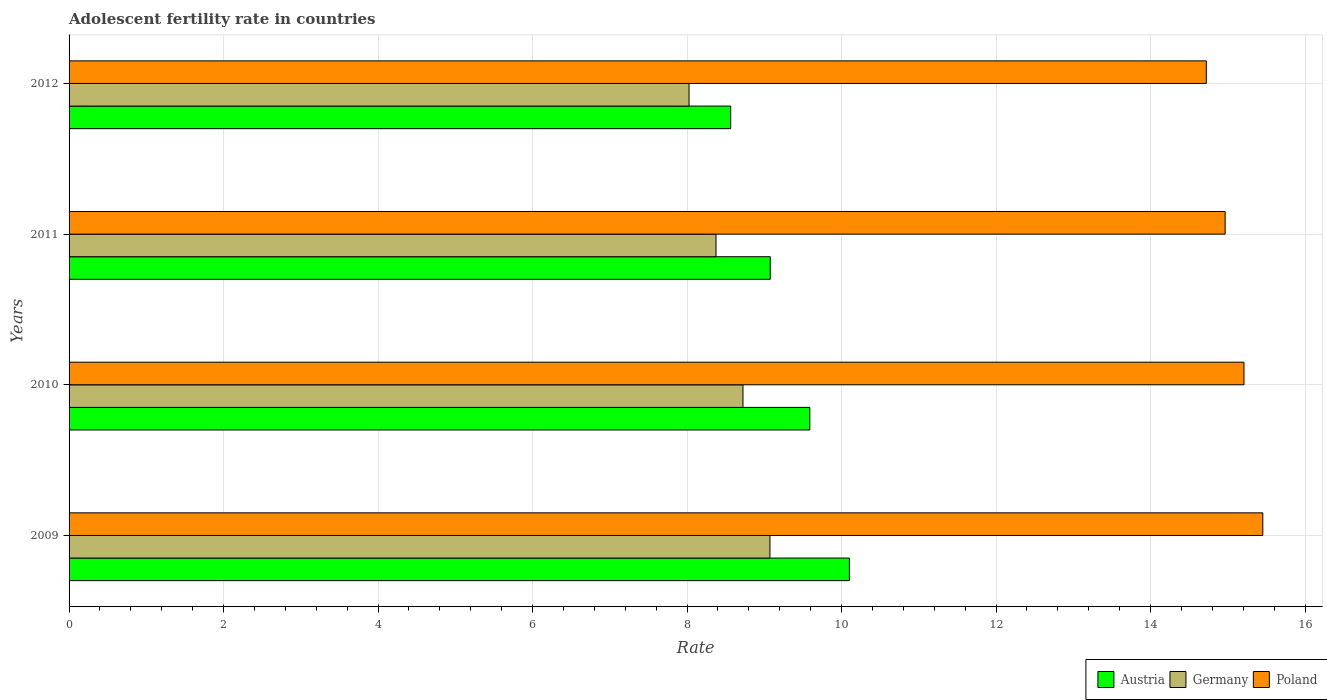How many different coloured bars are there?
Make the answer very short. 3. How many groups of bars are there?
Ensure brevity in your answer.  4. How many bars are there on the 3rd tick from the top?
Give a very brief answer. 3. What is the label of the 4th group of bars from the top?
Give a very brief answer. 2009. In how many cases, is the number of bars for a given year not equal to the number of legend labels?
Make the answer very short. 0. What is the adolescent fertility rate in Poland in 2012?
Your answer should be very brief. 14.72. Across all years, what is the maximum adolescent fertility rate in Austria?
Offer a terse response. 10.1. Across all years, what is the minimum adolescent fertility rate in Poland?
Offer a very short reply. 14.72. In which year was the adolescent fertility rate in Austria minimum?
Ensure brevity in your answer.  2012. What is the total adolescent fertility rate in Poland in the graph?
Provide a short and direct response. 60.35. What is the difference between the adolescent fertility rate in Austria in 2009 and that in 2010?
Give a very brief answer. 0.51. What is the difference between the adolescent fertility rate in Poland in 2011 and the adolescent fertility rate in Austria in 2012?
Your answer should be very brief. 6.4. What is the average adolescent fertility rate in Germany per year?
Your answer should be very brief. 8.55. In the year 2011, what is the difference between the adolescent fertility rate in Germany and adolescent fertility rate in Austria?
Offer a terse response. -0.7. In how many years, is the adolescent fertility rate in Austria greater than 15.6 ?
Your answer should be compact. 0. What is the ratio of the adolescent fertility rate in Poland in 2009 to that in 2010?
Offer a terse response. 1.02. Is the adolescent fertility rate in Poland in 2011 less than that in 2012?
Your response must be concise. No. Is the difference between the adolescent fertility rate in Germany in 2011 and 2012 greater than the difference between the adolescent fertility rate in Austria in 2011 and 2012?
Your answer should be compact. No. What is the difference between the highest and the second highest adolescent fertility rate in Germany?
Provide a short and direct response. 0.35. What is the difference between the highest and the lowest adolescent fertility rate in Germany?
Offer a very short reply. 1.05. In how many years, is the adolescent fertility rate in Poland greater than the average adolescent fertility rate in Poland taken over all years?
Your answer should be compact. 2. What does the 2nd bar from the top in 2009 represents?
Your answer should be compact. Germany. What does the 3rd bar from the bottom in 2009 represents?
Keep it short and to the point. Poland. How many bars are there?
Offer a very short reply. 12. How many years are there in the graph?
Keep it short and to the point. 4. What is the difference between two consecutive major ticks on the X-axis?
Your answer should be very brief. 2. Where does the legend appear in the graph?
Offer a very short reply. Bottom right. How many legend labels are there?
Your answer should be compact. 3. How are the legend labels stacked?
Make the answer very short. Horizontal. What is the title of the graph?
Provide a succinct answer. Adolescent fertility rate in countries. Does "Ecuador" appear as one of the legend labels in the graph?
Offer a terse response. No. What is the label or title of the X-axis?
Ensure brevity in your answer.  Rate. What is the Rate of Austria in 2009?
Ensure brevity in your answer.  10.1. What is the Rate in Germany in 2009?
Make the answer very short. 9.07. What is the Rate of Poland in 2009?
Give a very brief answer. 15.45. What is the Rate of Austria in 2010?
Give a very brief answer. 9.59. What is the Rate in Germany in 2010?
Offer a terse response. 8.72. What is the Rate of Poland in 2010?
Provide a succinct answer. 15.21. What is the Rate in Austria in 2011?
Your answer should be very brief. 9.08. What is the Rate of Germany in 2011?
Give a very brief answer. 8.38. What is the Rate of Poland in 2011?
Your answer should be compact. 14.97. What is the Rate in Austria in 2012?
Make the answer very short. 8.56. What is the Rate in Germany in 2012?
Ensure brevity in your answer.  8.03. What is the Rate of Poland in 2012?
Ensure brevity in your answer.  14.72. Across all years, what is the maximum Rate in Austria?
Provide a short and direct response. 10.1. Across all years, what is the maximum Rate of Germany?
Make the answer very short. 9.07. Across all years, what is the maximum Rate of Poland?
Provide a short and direct response. 15.45. Across all years, what is the minimum Rate of Austria?
Provide a succinct answer. 8.56. Across all years, what is the minimum Rate of Germany?
Your answer should be compact. 8.03. Across all years, what is the minimum Rate of Poland?
Give a very brief answer. 14.72. What is the total Rate in Austria in the graph?
Offer a terse response. 37.33. What is the total Rate in Germany in the graph?
Make the answer very short. 34.2. What is the total Rate of Poland in the graph?
Make the answer very short. 60.35. What is the difference between the Rate of Austria in 2009 and that in 2010?
Provide a short and direct response. 0.51. What is the difference between the Rate of Germany in 2009 and that in 2010?
Your response must be concise. 0.35. What is the difference between the Rate of Poland in 2009 and that in 2010?
Your answer should be compact. 0.24. What is the difference between the Rate of Austria in 2009 and that in 2011?
Your response must be concise. 1.02. What is the difference between the Rate in Germany in 2009 and that in 2011?
Your answer should be compact. 0.7. What is the difference between the Rate in Poland in 2009 and that in 2011?
Keep it short and to the point. 0.49. What is the difference between the Rate in Austria in 2009 and that in 2012?
Provide a short and direct response. 1.54. What is the difference between the Rate in Germany in 2009 and that in 2012?
Offer a very short reply. 1.05. What is the difference between the Rate of Poland in 2009 and that in 2012?
Your answer should be compact. 0.73. What is the difference between the Rate in Austria in 2010 and that in 2011?
Your answer should be compact. 0.51. What is the difference between the Rate in Germany in 2010 and that in 2011?
Provide a short and direct response. 0.35. What is the difference between the Rate of Poland in 2010 and that in 2011?
Provide a succinct answer. 0.24. What is the difference between the Rate of Austria in 2010 and that in 2012?
Provide a short and direct response. 1.02. What is the difference between the Rate of Germany in 2010 and that in 2012?
Keep it short and to the point. 0.7. What is the difference between the Rate in Poland in 2010 and that in 2012?
Offer a very short reply. 0.49. What is the difference between the Rate in Austria in 2011 and that in 2012?
Offer a very short reply. 0.51. What is the difference between the Rate in Germany in 2011 and that in 2012?
Offer a terse response. 0.35. What is the difference between the Rate in Poland in 2011 and that in 2012?
Offer a terse response. 0.24. What is the difference between the Rate of Austria in 2009 and the Rate of Germany in 2010?
Your answer should be compact. 1.38. What is the difference between the Rate in Austria in 2009 and the Rate in Poland in 2010?
Make the answer very short. -5.11. What is the difference between the Rate of Germany in 2009 and the Rate of Poland in 2010?
Your response must be concise. -6.14. What is the difference between the Rate in Austria in 2009 and the Rate in Germany in 2011?
Keep it short and to the point. 1.73. What is the difference between the Rate in Austria in 2009 and the Rate in Poland in 2011?
Keep it short and to the point. -4.86. What is the difference between the Rate in Germany in 2009 and the Rate in Poland in 2011?
Keep it short and to the point. -5.89. What is the difference between the Rate of Austria in 2009 and the Rate of Germany in 2012?
Give a very brief answer. 2.08. What is the difference between the Rate in Austria in 2009 and the Rate in Poland in 2012?
Give a very brief answer. -4.62. What is the difference between the Rate in Germany in 2009 and the Rate in Poland in 2012?
Offer a very short reply. -5.65. What is the difference between the Rate in Austria in 2010 and the Rate in Germany in 2011?
Ensure brevity in your answer.  1.21. What is the difference between the Rate of Austria in 2010 and the Rate of Poland in 2011?
Keep it short and to the point. -5.38. What is the difference between the Rate in Germany in 2010 and the Rate in Poland in 2011?
Offer a very short reply. -6.24. What is the difference between the Rate of Austria in 2010 and the Rate of Germany in 2012?
Offer a terse response. 1.56. What is the difference between the Rate in Austria in 2010 and the Rate in Poland in 2012?
Your answer should be very brief. -5.13. What is the difference between the Rate of Germany in 2010 and the Rate of Poland in 2012?
Offer a terse response. -6. What is the difference between the Rate in Austria in 2011 and the Rate in Germany in 2012?
Your response must be concise. 1.05. What is the difference between the Rate of Austria in 2011 and the Rate of Poland in 2012?
Your answer should be compact. -5.64. What is the difference between the Rate of Germany in 2011 and the Rate of Poland in 2012?
Your answer should be compact. -6.35. What is the average Rate of Austria per year?
Offer a terse response. 9.33. What is the average Rate of Germany per year?
Your answer should be very brief. 8.55. What is the average Rate of Poland per year?
Your response must be concise. 15.09. In the year 2009, what is the difference between the Rate of Austria and Rate of Germany?
Keep it short and to the point. 1.03. In the year 2009, what is the difference between the Rate of Austria and Rate of Poland?
Make the answer very short. -5.35. In the year 2009, what is the difference between the Rate of Germany and Rate of Poland?
Make the answer very short. -6.38. In the year 2010, what is the difference between the Rate in Austria and Rate in Germany?
Your response must be concise. 0.87. In the year 2010, what is the difference between the Rate of Austria and Rate of Poland?
Provide a succinct answer. -5.62. In the year 2010, what is the difference between the Rate in Germany and Rate in Poland?
Your response must be concise. -6.49. In the year 2011, what is the difference between the Rate of Austria and Rate of Germany?
Give a very brief answer. 0.7. In the year 2011, what is the difference between the Rate in Austria and Rate in Poland?
Keep it short and to the point. -5.89. In the year 2011, what is the difference between the Rate of Germany and Rate of Poland?
Make the answer very short. -6.59. In the year 2012, what is the difference between the Rate in Austria and Rate in Germany?
Make the answer very short. 0.54. In the year 2012, what is the difference between the Rate of Austria and Rate of Poland?
Offer a very short reply. -6.16. In the year 2012, what is the difference between the Rate in Germany and Rate in Poland?
Your answer should be compact. -6.7. What is the ratio of the Rate of Austria in 2009 to that in 2010?
Your response must be concise. 1.05. What is the ratio of the Rate of Germany in 2009 to that in 2010?
Your response must be concise. 1.04. What is the ratio of the Rate in Austria in 2009 to that in 2011?
Your answer should be very brief. 1.11. What is the ratio of the Rate of Poland in 2009 to that in 2011?
Your answer should be compact. 1.03. What is the ratio of the Rate in Austria in 2009 to that in 2012?
Provide a succinct answer. 1.18. What is the ratio of the Rate of Germany in 2009 to that in 2012?
Your answer should be compact. 1.13. What is the ratio of the Rate in Poland in 2009 to that in 2012?
Keep it short and to the point. 1.05. What is the ratio of the Rate of Austria in 2010 to that in 2011?
Provide a short and direct response. 1.06. What is the ratio of the Rate of Germany in 2010 to that in 2011?
Ensure brevity in your answer.  1.04. What is the ratio of the Rate of Poland in 2010 to that in 2011?
Offer a very short reply. 1.02. What is the ratio of the Rate of Austria in 2010 to that in 2012?
Keep it short and to the point. 1.12. What is the ratio of the Rate of Germany in 2010 to that in 2012?
Make the answer very short. 1.09. What is the ratio of the Rate in Poland in 2010 to that in 2012?
Provide a short and direct response. 1.03. What is the ratio of the Rate in Austria in 2011 to that in 2012?
Your response must be concise. 1.06. What is the ratio of the Rate of Germany in 2011 to that in 2012?
Your response must be concise. 1.04. What is the ratio of the Rate in Poland in 2011 to that in 2012?
Provide a succinct answer. 1.02. What is the difference between the highest and the second highest Rate in Austria?
Your answer should be very brief. 0.51. What is the difference between the highest and the second highest Rate of Germany?
Provide a short and direct response. 0.35. What is the difference between the highest and the second highest Rate of Poland?
Make the answer very short. 0.24. What is the difference between the highest and the lowest Rate in Austria?
Offer a terse response. 1.54. What is the difference between the highest and the lowest Rate in Germany?
Keep it short and to the point. 1.05. What is the difference between the highest and the lowest Rate of Poland?
Make the answer very short. 0.73. 